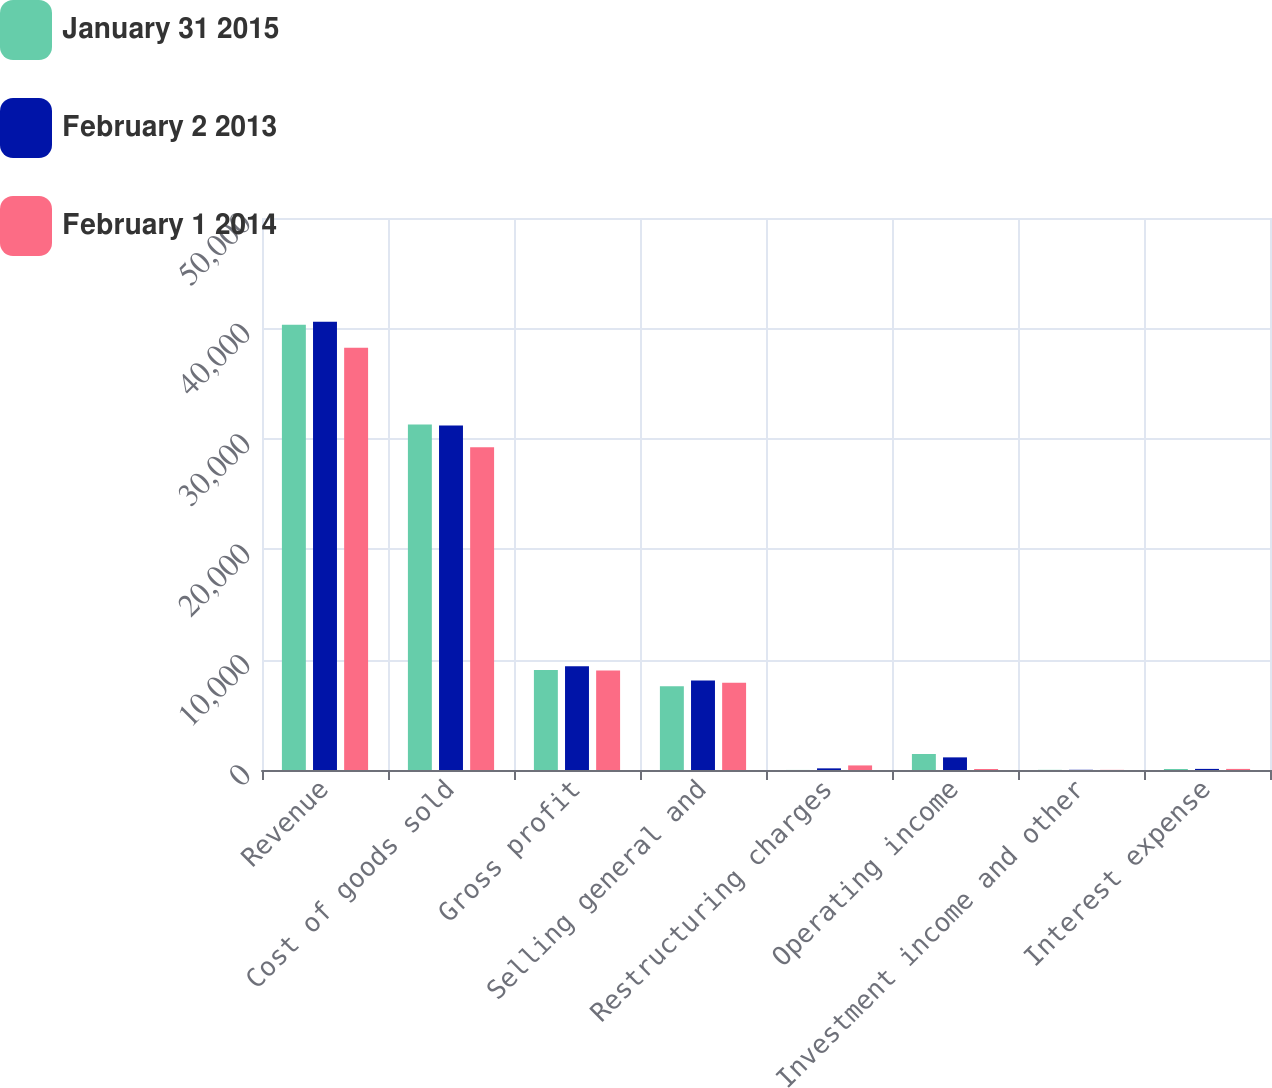Convert chart. <chart><loc_0><loc_0><loc_500><loc_500><stacked_bar_chart><ecel><fcel>Revenue<fcel>Cost of goods sold<fcel>Gross profit<fcel>Selling general and<fcel>Restructuring charges<fcel>Operating income<fcel>Investment income and other<fcel>Interest expense<nl><fcel>January 31 2015<fcel>40339<fcel>31292<fcel>9047<fcel>7592<fcel>5<fcel>1450<fcel>14<fcel>90<nl><fcel>February 2 2013<fcel>40611<fcel>31212<fcel>9399<fcel>8106<fcel>149<fcel>1144<fcel>19<fcel>100<nl><fcel>February 1 2014<fcel>38252<fcel>29228<fcel>9023<fcel>7905<fcel>414<fcel>90<fcel>13<fcel>99<nl></chart> 